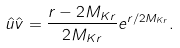Convert formula to latex. <formula><loc_0><loc_0><loc_500><loc_500>\hat { u } \hat { v } = \frac { r - 2 M _ { K r } } { 2 M _ { K r } } e ^ { r / 2 M _ { K r } } .</formula> 